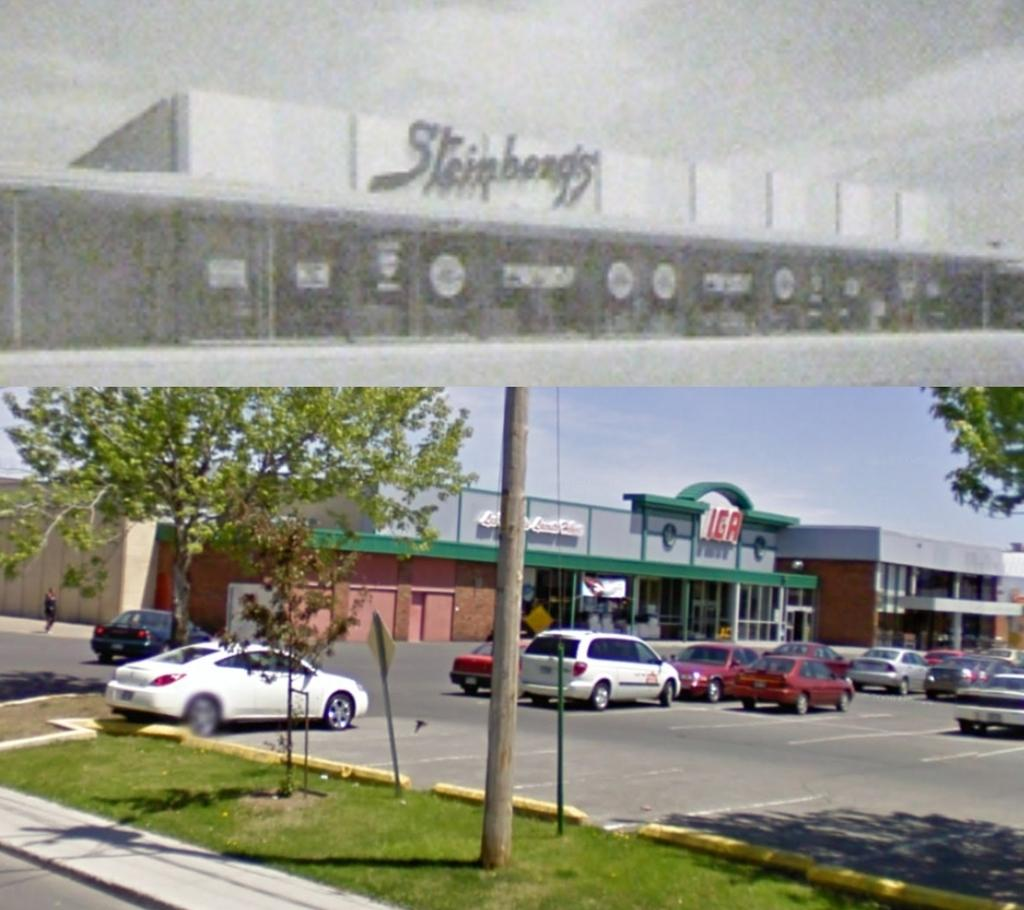How many pictures are in the image? There are two pictures in the image. What can be seen at the bottom of the picture? At the bottom of the picture, there are vehicles, a road, grass, trees, stores, and sky. What is present at the top of the picture? At the top of the picture, there is a storyboard and sky. What type of treatment is being administered to the trees in the image? There is no treatment being administered to the trees in the image; they are simply present in the scene. What route is the storyboard following in the image? The storyboard is not following a route in the image; it is a static visual element. 